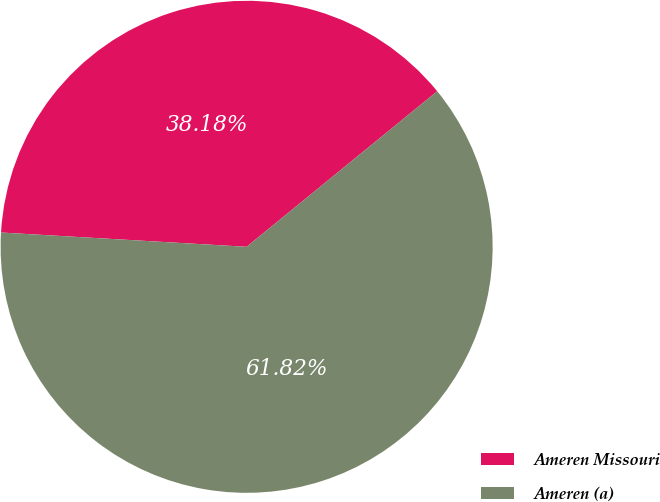Convert chart to OTSL. <chart><loc_0><loc_0><loc_500><loc_500><pie_chart><fcel>Ameren Missouri<fcel>Ameren (a)<nl><fcel>38.18%<fcel>61.82%<nl></chart> 